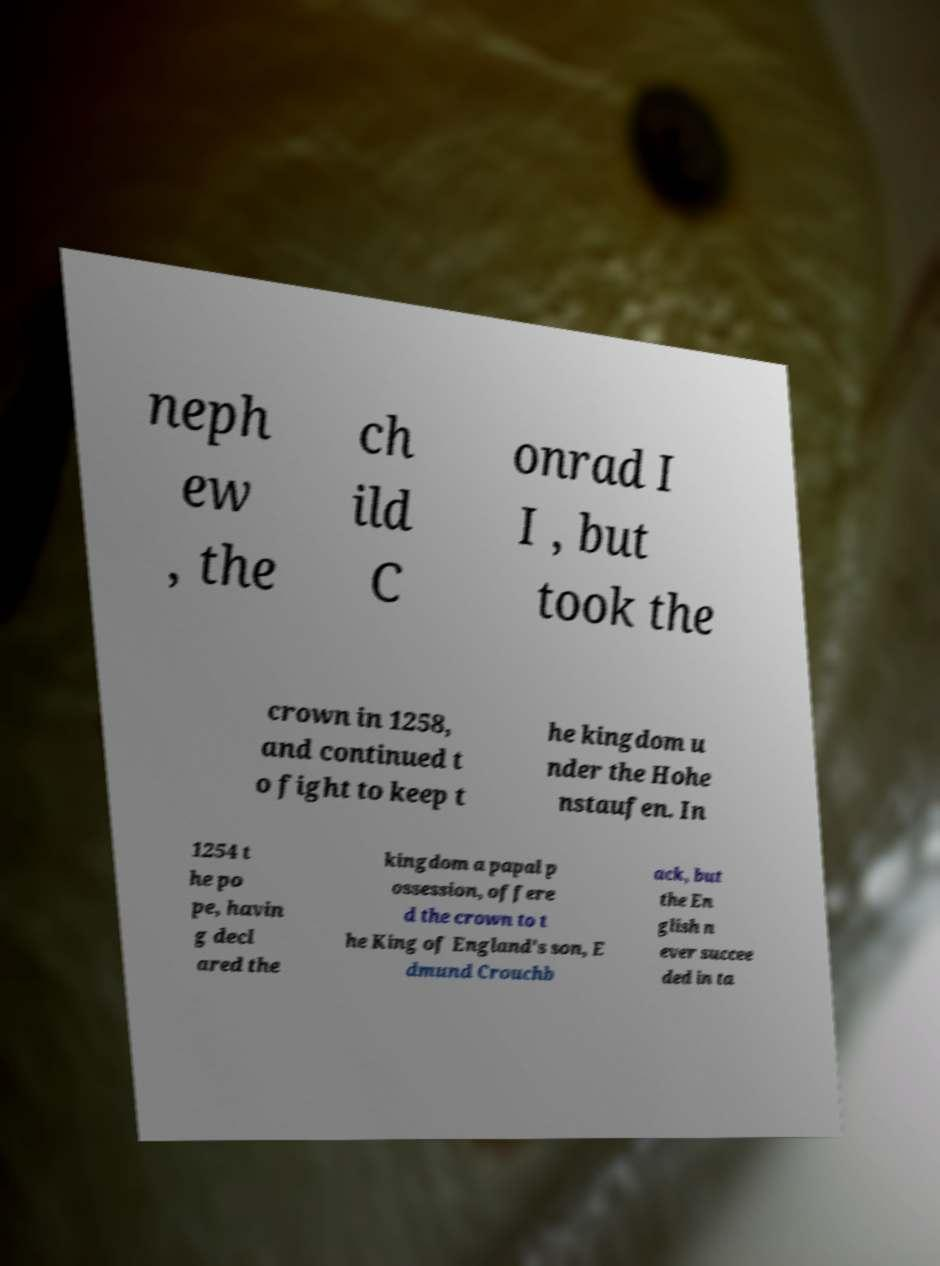Could you assist in decoding the text presented in this image and type it out clearly? neph ew , the ch ild C onrad I I , but took the crown in 1258, and continued t o fight to keep t he kingdom u nder the Hohe nstaufen. In 1254 t he po pe, havin g decl ared the kingdom a papal p ossession, offere d the crown to t he King of England's son, E dmund Crouchb ack, but the En glish n ever succee ded in ta 